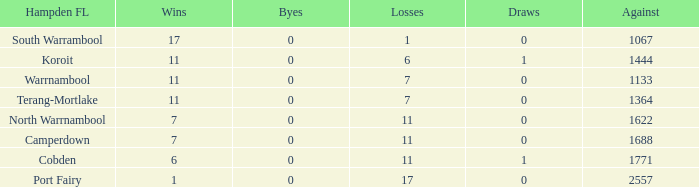What were the losses when the byes were negative? None. 